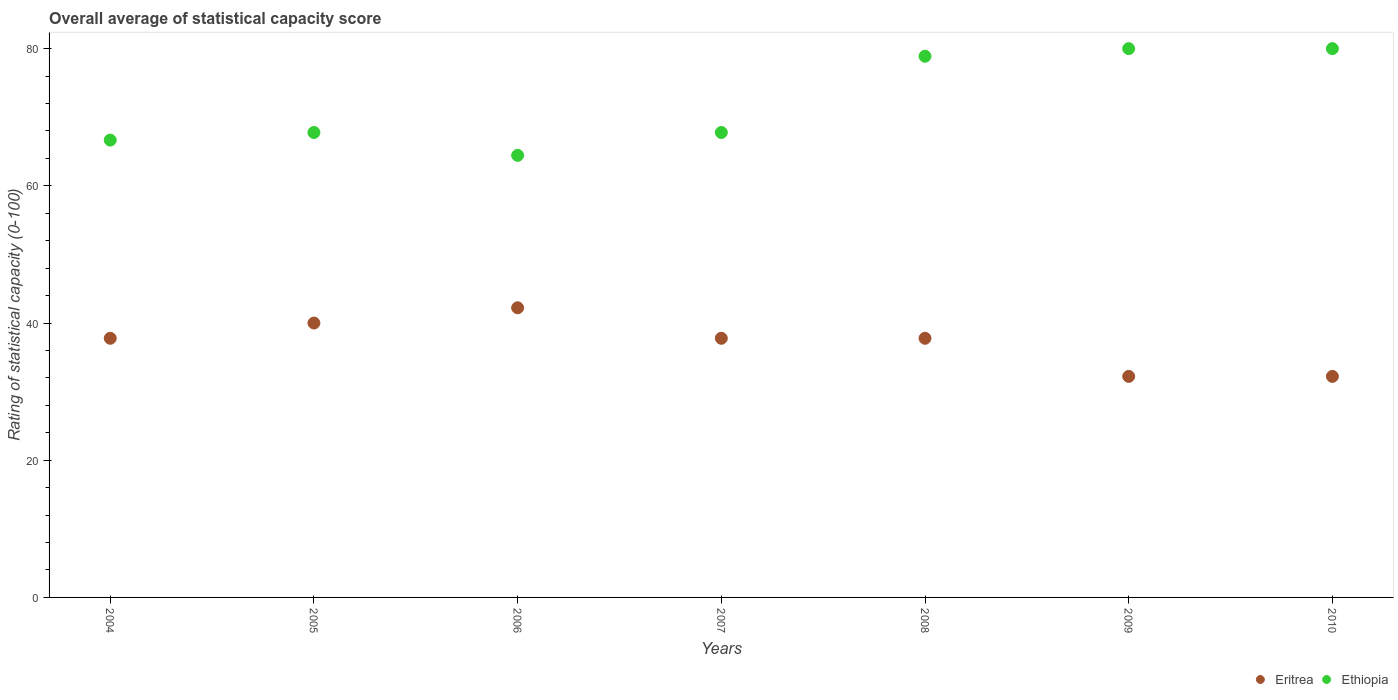How many different coloured dotlines are there?
Make the answer very short. 2. Is the number of dotlines equal to the number of legend labels?
Make the answer very short. Yes. What is the rating of statistical capacity in Ethiopia in 2004?
Your answer should be very brief. 66.67. Across all years, what is the minimum rating of statistical capacity in Eritrea?
Make the answer very short. 32.22. In which year was the rating of statistical capacity in Eritrea maximum?
Provide a succinct answer. 2006. In which year was the rating of statistical capacity in Eritrea minimum?
Ensure brevity in your answer.  2009. What is the total rating of statistical capacity in Ethiopia in the graph?
Keep it short and to the point. 505.56. What is the difference between the rating of statistical capacity in Eritrea in 2006 and that in 2009?
Provide a short and direct response. 10. What is the difference between the rating of statistical capacity in Eritrea in 2005 and the rating of statistical capacity in Ethiopia in 2010?
Your response must be concise. -40. What is the average rating of statistical capacity in Ethiopia per year?
Your response must be concise. 72.22. In the year 2010, what is the difference between the rating of statistical capacity in Eritrea and rating of statistical capacity in Ethiopia?
Provide a succinct answer. -47.78. Is the rating of statistical capacity in Eritrea in 2004 less than that in 2005?
Offer a very short reply. Yes. What is the difference between the highest and the lowest rating of statistical capacity in Eritrea?
Give a very brief answer. 10. In how many years, is the rating of statistical capacity in Eritrea greater than the average rating of statistical capacity in Eritrea taken over all years?
Ensure brevity in your answer.  5. Does the rating of statistical capacity in Eritrea monotonically increase over the years?
Your response must be concise. No. How many dotlines are there?
Offer a very short reply. 2. Are the values on the major ticks of Y-axis written in scientific E-notation?
Your answer should be very brief. No. Does the graph contain any zero values?
Offer a terse response. No. Does the graph contain grids?
Offer a terse response. No. How are the legend labels stacked?
Provide a succinct answer. Horizontal. What is the title of the graph?
Keep it short and to the point. Overall average of statistical capacity score. Does "Tanzania" appear as one of the legend labels in the graph?
Provide a short and direct response. No. What is the label or title of the X-axis?
Make the answer very short. Years. What is the label or title of the Y-axis?
Offer a very short reply. Rating of statistical capacity (0-100). What is the Rating of statistical capacity (0-100) in Eritrea in 2004?
Keep it short and to the point. 37.78. What is the Rating of statistical capacity (0-100) of Ethiopia in 2004?
Provide a short and direct response. 66.67. What is the Rating of statistical capacity (0-100) in Ethiopia in 2005?
Your answer should be compact. 67.78. What is the Rating of statistical capacity (0-100) in Eritrea in 2006?
Provide a succinct answer. 42.22. What is the Rating of statistical capacity (0-100) of Ethiopia in 2006?
Provide a succinct answer. 64.44. What is the Rating of statistical capacity (0-100) in Eritrea in 2007?
Make the answer very short. 37.78. What is the Rating of statistical capacity (0-100) of Ethiopia in 2007?
Your answer should be very brief. 67.78. What is the Rating of statistical capacity (0-100) of Eritrea in 2008?
Give a very brief answer. 37.78. What is the Rating of statistical capacity (0-100) of Ethiopia in 2008?
Provide a short and direct response. 78.89. What is the Rating of statistical capacity (0-100) in Eritrea in 2009?
Give a very brief answer. 32.22. What is the Rating of statistical capacity (0-100) in Eritrea in 2010?
Keep it short and to the point. 32.22. What is the Rating of statistical capacity (0-100) in Ethiopia in 2010?
Make the answer very short. 80. Across all years, what is the maximum Rating of statistical capacity (0-100) in Eritrea?
Provide a succinct answer. 42.22. Across all years, what is the minimum Rating of statistical capacity (0-100) of Eritrea?
Offer a terse response. 32.22. Across all years, what is the minimum Rating of statistical capacity (0-100) of Ethiopia?
Give a very brief answer. 64.44. What is the total Rating of statistical capacity (0-100) in Eritrea in the graph?
Your answer should be compact. 260. What is the total Rating of statistical capacity (0-100) in Ethiopia in the graph?
Offer a very short reply. 505.56. What is the difference between the Rating of statistical capacity (0-100) in Eritrea in 2004 and that in 2005?
Give a very brief answer. -2.22. What is the difference between the Rating of statistical capacity (0-100) in Ethiopia in 2004 and that in 2005?
Make the answer very short. -1.11. What is the difference between the Rating of statistical capacity (0-100) in Eritrea in 2004 and that in 2006?
Your answer should be compact. -4.44. What is the difference between the Rating of statistical capacity (0-100) in Ethiopia in 2004 and that in 2006?
Offer a very short reply. 2.22. What is the difference between the Rating of statistical capacity (0-100) of Ethiopia in 2004 and that in 2007?
Provide a succinct answer. -1.11. What is the difference between the Rating of statistical capacity (0-100) in Ethiopia in 2004 and that in 2008?
Your answer should be very brief. -12.22. What is the difference between the Rating of statistical capacity (0-100) in Eritrea in 2004 and that in 2009?
Your answer should be very brief. 5.56. What is the difference between the Rating of statistical capacity (0-100) in Ethiopia in 2004 and that in 2009?
Provide a short and direct response. -13.33. What is the difference between the Rating of statistical capacity (0-100) of Eritrea in 2004 and that in 2010?
Make the answer very short. 5.56. What is the difference between the Rating of statistical capacity (0-100) of Ethiopia in 2004 and that in 2010?
Your answer should be compact. -13.33. What is the difference between the Rating of statistical capacity (0-100) of Eritrea in 2005 and that in 2006?
Offer a very short reply. -2.22. What is the difference between the Rating of statistical capacity (0-100) in Ethiopia in 2005 and that in 2006?
Your answer should be compact. 3.33. What is the difference between the Rating of statistical capacity (0-100) of Eritrea in 2005 and that in 2007?
Provide a succinct answer. 2.22. What is the difference between the Rating of statistical capacity (0-100) in Ethiopia in 2005 and that in 2007?
Provide a succinct answer. 0. What is the difference between the Rating of statistical capacity (0-100) in Eritrea in 2005 and that in 2008?
Make the answer very short. 2.22. What is the difference between the Rating of statistical capacity (0-100) of Ethiopia in 2005 and that in 2008?
Provide a short and direct response. -11.11. What is the difference between the Rating of statistical capacity (0-100) of Eritrea in 2005 and that in 2009?
Provide a short and direct response. 7.78. What is the difference between the Rating of statistical capacity (0-100) of Ethiopia in 2005 and that in 2009?
Ensure brevity in your answer.  -12.22. What is the difference between the Rating of statistical capacity (0-100) of Eritrea in 2005 and that in 2010?
Your answer should be compact. 7.78. What is the difference between the Rating of statistical capacity (0-100) of Ethiopia in 2005 and that in 2010?
Make the answer very short. -12.22. What is the difference between the Rating of statistical capacity (0-100) in Eritrea in 2006 and that in 2007?
Provide a short and direct response. 4.44. What is the difference between the Rating of statistical capacity (0-100) in Eritrea in 2006 and that in 2008?
Provide a short and direct response. 4.44. What is the difference between the Rating of statistical capacity (0-100) in Ethiopia in 2006 and that in 2008?
Offer a terse response. -14.44. What is the difference between the Rating of statistical capacity (0-100) of Ethiopia in 2006 and that in 2009?
Make the answer very short. -15.56. What is the difference between the Rating of statistical capacity (0-100) of Ethiopia in 2006 and that in 2010?
Make the answer very short. -15.56. What is the difference between the Rating of statistical capacity (0-100) of Eritrea in 2007 and that in 2008?
Make the answer very short. 0. What is the difference between the Rating of statistical capacity (0-100) of Ethiopia in 2007 and that in 2008?
Your response must be concise. -11.11. What is the difference between the Rating of statistical capacity (0-100) of Eritrea in 2007 and that in 2009?
Your answer should be very brief. 5.56. What is the difference between the Rating of statistical capacity (0-100) of Ethiopia in 2007 and that in 2009?
Ensure brevity in your answer.  -12.22. What is the difference between the Rating of statistical capacity (0-100) in Eritrea in 2007 and that in 2010?
Make the answer very short. 5.56. What is the difference between the Rating of statistical capacity (0-100) in Ethiopia in 2007 and that in 2010?
Make the answer very short. -12.22. What is the difference between the Rating of statistical capacity (0-100) in Eritrea in 2008 and that in 2009?
Provide a succinct answer. 5.56. What is the difference between the Rating of statistical capacity (0-100) in Ethiopia in 2008 and that in 2009?
Keep it short and to the point. -1.11. What is the difference between the Rating of statistical capacity (0-100) of Eritrea in 2008 and that in 2010?
Give a very brief answer. 5.56. What is the difference between the Rating of statistical capacity (0-100) in Ethiopia in 2008 and that in 2010?
Make the answer very short. -1.11. What is the difference between the Rating of statistical capacity (0-100) in Eritrea in 2009 and that in 2010?
Make the answer very short. 0. What is the difference between the Rating of statistical capacity (0-100) in Eritrea in 2004 and the Rating of statistical capacity (0-100) in Ethiopia in 2006?
Offer a terse response. -26.67. What is the difference between the Rating of statistical capacity (0-100) of Eritrea in 2004 and the Rating of statistical capacity (0-100) of Ethiopia in 2007?
Your answer should be compact. -30. What is the difference between the Rating of statistical capacity (0-100) of Eritrea in 2004 and the Rating of statistical capacity (0-100) of Ethiopia in 2008?
Your answer should be very brief. -41.11. What is the difference between the Rating of statistical capacity (0-100) of Eritrea in 2004 and the Rating of statistical capacity (0-100) of Ethiopia in 2009?
Make the answer very short. -42.22. What is the difference between the Rating of statistical capacity (0-100) of Eritrea in 2004 and the Rating of statistical capacity (0-100) of Ethiopia in 2010?
Keep it short and to the point. -42.22. What is the difference between the Rating of statistical capacity (0-100) of Eritrea in 2005 and the Rating of statistical capacity (0-100) of Ethiopia in 2006?
Provide a succinct answer. -24.44. What is the difference between the Rating of statistical capacity (0-100) in Eritrea in 2005 and the Rating of statistical capacity (0-100) in Ethiopia in 2007?
Offer a terse response. -27.78. What is the difference between the Rating of statistical capacity (0-100) in Eritrea in 2005 and the Rating of statistical capacity (0-100) in Ethiopia in 2008?
Your answer should be very brief. -38.89. What is the difference between the Rating of statistical capacity (0-100) in Eritrea in 2005 and the Rating of statistical capacity (0-100) in Ethiopia in 2009?
Your answer should be compact. -40. What is the difference between the Rating of statistical capacity (0-100) of Eritrea in 2005 and the Rating of statistical capacity (0-100) of Ethiopia in 2010?
Your response must be concise. -40. What is the difference between the Rating of statistical capacity (0-100) in Eritrea in 2006 and the Rating of statistical capacity (0-100) in Ethiopia in 2007?
Ensure brevity in your answer.  -25.56. What is the difference between the Rating of statistical capacity (0-100) in Eritrea in 2006 and the Rating of statistical capacity (0-100) in Ethiopia in 2008?
Offer a terse response. -36.67. What is the difference between the Rating of statistical capacity (0-100) in Eritrea in 2006 and the Rating of statistical capacity (0-100) in Ethiopia in 2009?
Your answer should be very brief. -37.78. What is the difference between the Rating of statistical capacity (0-100) in Eritrea in 2006 and the Rating of statistical capacity (0-100) in Ethiopia in 2010?
Give a very brief answer. -37.78. What is the difference between the Rating of statistical capacity (0-100) of Eritrea in 2007 and the Rating of statistical capacity (0-100) of Ethiopia in 2008?
Your answer should be very brief. -41.11. What is the difference between the Rating of statistical capacity (0-100) in Eritrea in 2007 and the Rating of statistical capacity (0-100) in Ethiopia in 2009?
Ensure brevity in your answer.  -42.22. What is the difference between the Rating of statistical capacity (0-100) of Eritrea in 2007 and the Rating of statistical capacity (0-100) of Ethiopia in 2010?
Keep it short and to the point. -42.22. What is the difference between the Rating of statistical capacity (0-100) in Eritrea in 2008 and the Rating of statistical capacity (0-100) in Ethiopia in 2009?
Your answer should be very brief. -42.22. What is the difference between the Rating of statistical capacity (0-100) of Eritrea in 2008 and the Rating of statistical capacity (0-100) of Ethiopia in 2010?
Offer a very short reply. -42.22. What is the difference between the Rating of statistical capacity (0-100) of Eritrea in 2009 and the Rating of statistical capacity (0-100) of Ethiopia in 2010?
Your response must be concise. -47.78. What is the average Rating of statistical capacity (0-100) in Eritrea per year?
Your response must be concise. 37.14. What is the average Rating of statistical capacity (0-100) of Ethiopia per year?
Your answer should be compact. 72.22. In the year 2004, what is the difference between the Rating of statistical capacity (0-100) of Eritrea and Rating of statistical capacity (0-100) of Ethiopia?
Your response must be concise. -28.89. In the year 2005, what is the difference between the Rating of statistical capacity (0-100) of Eritrea and Rating of statistical capacity (0-100) of Ethiopia?
Make the answer very short. -27.78. In the year 2006, what is the difference between the Rating of statistical capacity (0-100) of Eritrea and Rating of statistical capacity (0-100) of Ethiopia?
Give a very brief answer. -22.22. In the year 2008, what is the difference between the Rating of statistical capacity (0-100) in Eritrea and Rating of statistical capacity (0-100) in Ethiopia?
Keep it short and to the point. -41.11. In the year 2009, what is the difference between the Rating of statistical capacity (0-100) in Eritrea and Rating of statistical capacity (0-100) in Ethiopia?
Make the answer very short. -47.78. In the year 2010, what is the difference between the Rating of statistical capacity (0-100) of Eritrea and Rating of statistical capacity (0-100) of Ethiopia?
Provide a short and direct response. -47.78. What is the ratio of the Rating of statistical capacity (0-100) of Ethiopia in 2004 to that in 2005?
Provide a short and direct response. 0.98. What is the ratio of the Rating of statistical capacity (0-100) in Eritrea in 2004 to that in 2006?
Offer a terse response. 0.89. What is the ratio of the Rating of statistical capacity (0-100) of Ethiopia in 2004 to that in 2006?
Offer a very short reply. 1.03. What is the ratio of the Rating of statistical capacity (0-100) of Eritrea in 2004 to that in 2007?
Provide a short and direct response. 1. What is the ratio of the Rating of statistical capacity (0-100) of Ethiopia in 2004 to that in 2007?
Your response must be concise. 0.98. What is the ratio of the Rating of statistical capacity (0-100) in Eritrea in 2004 to that in 2008?
Offer a terse response. 1. What is the ratio of the Rating of statistical capacity (0-100) of Ethiopia in 2004 to that in 2008?
Your response must be concise. 0.85. What is the ratio of the Rating of statistical capacity (0-100) of Eritrea in 2004 to that in 2009?
Provide a succinct answer. 1.17. What is the ratio of the Rating of statistical capacity (0-100) in Eritrea in 2004 to that in 2010?
Provide a short and direct response. 1.17. What is the ratio of the Rating of statistical capacity (0-100) of Eritrea in 2005 to that in 2006?
Your answer should be compact. 0.95. What is the ratio of the Rating of statistical capacity (0-100) in Ethiopia in 2005 to that in 2006?
Keep it short and to the point. 1.05. What is the ratio of the Rating of statistical capacity (0-100) in Eritrea in 2005 to that in 2007?
Provide a short and direct response. 1.06. What is the ratio of the Rating of statistical capacity (0-100) in Ethiopia in 2005 to that in 2007?
Your answer should be compact. 1. What is the ratio of the Rating of statistical capacity (0-100) in Eritrea in 2005 to that in 2008?
Ensure brevity in your answer.  1.06. What is the ratio of the Rating of statistical capacity (0-100) in Ethiopia in 2005 to that in 2008?
Offer a very short reply. 0.86. What is the ratio of the Rating of statistical capacity (0-100) of Eritrea in 2005 to that in 2009?
Provide a short and direct response. 1.24. What is the ratio of the Rating of statistical capacity (0-100) in Ethiopia in 2005 to that in 2009?
Give a very brief answer. 0.85. What is the ratio of the Rating of statistical capacity (0-100) in Eritrea in 2005 to that in 2010?
Make the answer very short. 1.24. What is the ratio of the Rating of statistical capacity (0-100) in Ethiopia in 2005 to that in 2010?
Offer a terse response. 0.85. What is the ratio of the Rating of statistical capacity (0-100) of Eritrea in 2006 to that in 2007?
Offer a terse response. 1.12. What is the ratio of the Rating of statistical capacity (0-100) of Ethiopia in 2006 to that in 2007?
Ensure brevity in your answer.  0.95. What is the ratio of the Rating of statistical capacity (0-100) in Eritrea in 2006 to that in 2008?
Give a very brief answer. 1.12. What is the ratio of the Rating of statistical capacity (0-100) of Ethiopia in 2006 to that in 2008?
Your answer should be very brief. 0.82. What is the ratio of the Rating of statistical capacity (0-100) of Eritrea in 2006 to that in 2009?
Provide a short and direct response. 1.31. What is the ratio of the Rating of statistical capacity (0-100) in Ethiopia in 2006 to that in 2009?
Provide a succinct answer. 0.81. What is the ratio of the Rating of statistical capacity (0-100) of Eritrea in 2006 to that in 2010?
Offer a very short reply. 1.31. What is the ratio of the Rating of statistical capacity (0-100) of Ethiopia in 2006 to that in 2010?
Offer a very short reply. 0.81. What is the ratio of the Rating of statistical capacity (0-100) of Eritrea in 2007 to that in 2008?
Give a very brief answer. 1. What is the ratio of the Rating of statistical capacity (0-100) of Ethiopia in 2007 to that in 2008?
Give a very brief answer. 0.86. What is the ratio of the Rating of statistical capacity (0-100) of Eritrea in 2007 to that in 2009?
Provide a short and direct response. 1.17. What is the ratio of the Rating of statistical capacity (0-100) in Ethiopia in 2007 to that in 2009?
Give a very brief answer. 0.85. What is the ratio of the Rating of statistical capacity (0-100) of Eritrea in 2007 to that in 2010?
Provide a succinct answer. 1.17. What is the ratio of the Rating of statistical capacity (0-100) of Ethiopia in 2007 to that in 2010?
Your response must be concise. 0.85. What is the ratio of the Rating of statistical capacity (0-100) in Eritrea in 2008 to that in 2009?
Provide a succinct answer. 1.17. What is the ratio of the Rating of statistical capacity (0-100) in Ethiopia in 2008 to that in 2009?
Make the answer very short. 0.99. What is the ratio of the Rating of statistical capacity (0-100) in Eritrea in 2008 to that in 2010?
Your response must be concise. 1.17. What is the ratio of the Rating of statistical capacity (0-100) in Ethiopia in 2008 to that in 2010?
Your answer should be compact. 0.99. What is the ratio of the Rating of statistical capacity (0-100) of Eritrea in 2009 to that in 2010?
Keep it short and to the point. 1. What is the difference between the highest and the second highest Rating of statistical capacity (0-100) in Eritrea?
Offer a terse response. 2.22. What is the difference between the highest and the lowest Rating of statistical capacity (0-100) of Eritrea?
Keep it short and to the point. 10. What is the difference between the highest and the lowest Rating of statistical capacity (0-100) of Ethiopia?
Keep it short and to the point. 15.56. 